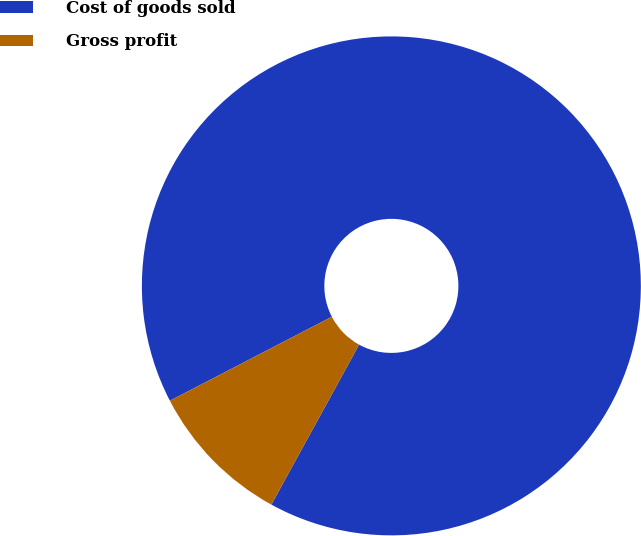Convert chart. <chart><loc_0><loc_0><loc_500><loc_500><pie_chart><fcel>Cost of goods sold<fcel>Gross profit<nl><fcel>90.6%<fcel>9.4%<nl></chart> 